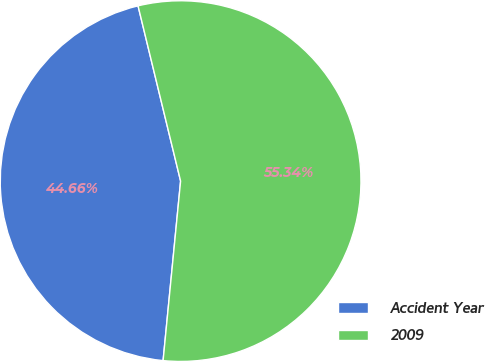Convert chart to OTSL. <chart><loc_0><loc_0><loc_500><loc_500><pie_chart><fcel>Accident Year<fcel>2009<nl><fcel>44.66%<fcel>55.34%<nl></chart> 